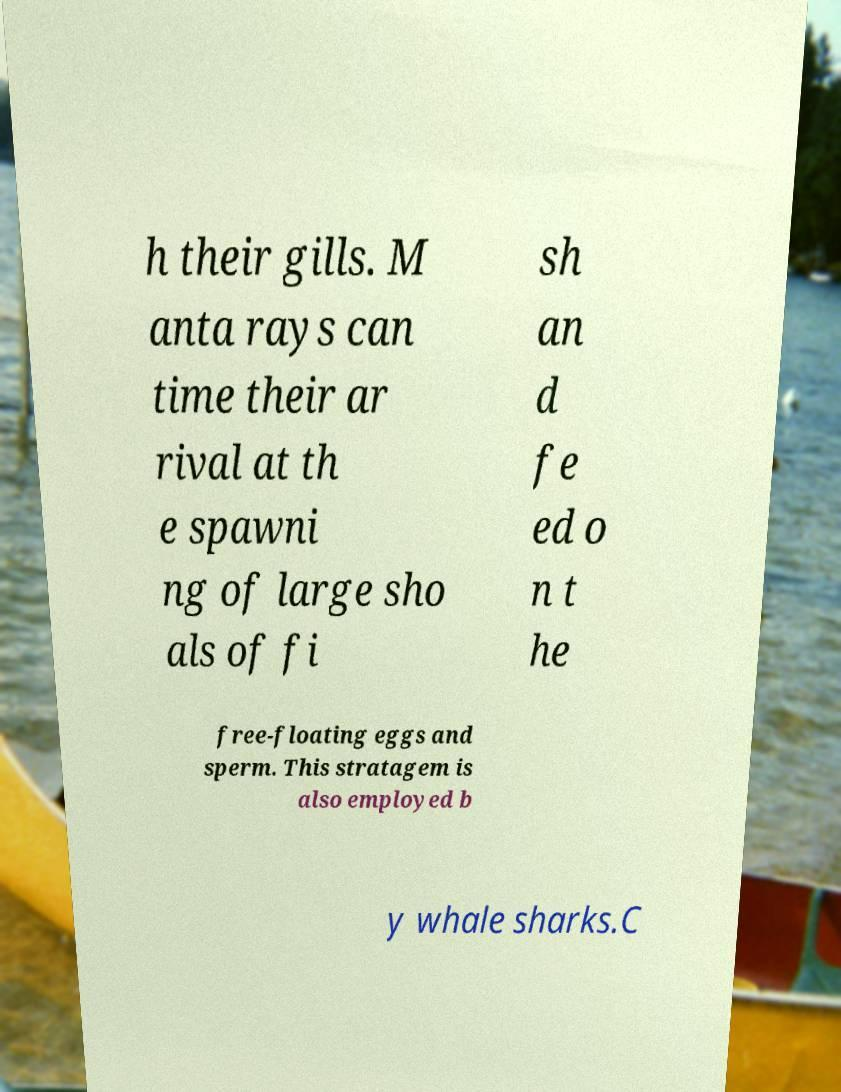Could you extract and type out the text from this image? h their gills. M anta rays can time their ar rival at th e spawni ng of large sho als of fi sh an d fe ed o n t he free-floating eggs and sperm. This stratagem is also employed b y whale sharks.C 